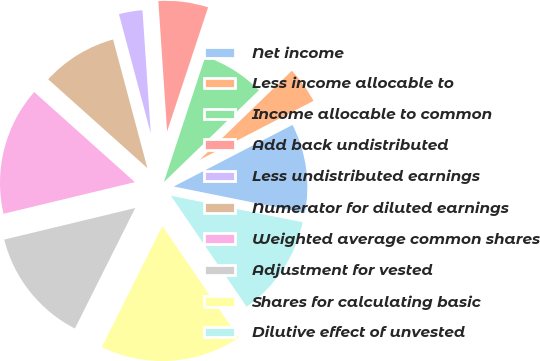Convert chart to OTSL. <chart><loc_0><loc_0><loc_500><loc_500><pie_chart><fcel>Net income<fcel>Less income allocable to<fcel>Income allocable to common<fcel>Add back undistributed<fcel>Less undistributed earnings<fcel>Numerator for diluted earnings<fcel>Weighted average common shares<fcel>Adjustment for vested<fcel>Shares for calculating basic<fcel>Dilutive effect of unvested<nl><fcel>10.77%<fcel>4.62%<fcel>7.69%<fcel>6.15%<fcel>3.08%<fcel>9.23%<fcel>15.38%<fcel>13.85%<fcel>16.92%<fcel>12.31%<nl></chart> 